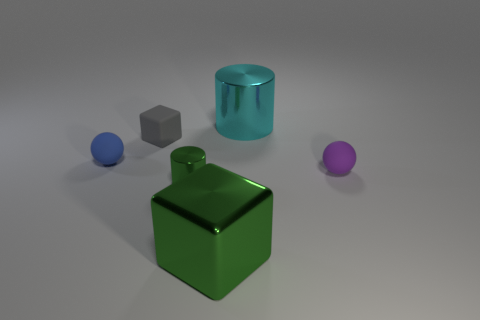Is the number of large metallic cylinders greater than the number of cylinders?
Ensure brevity in your answer.  No. Do the matte ball that is left of the small green metallic object and the big shiny cylinder have the same color?
Your answer should be compact. No. The tiny matte block has what color?
Your answer should be compact. Gray. Are there any small things to the left of the block that is on the right side of the small metal object?
Your answer should be compact. Yes. What is the shape of the object in front of the metal cylinder in front of the purple rubber sphere?
Provide a short and direct response. Cube. Are there fewer tiny yellow matte spheres than green things?
Make the answer very short. Yes. Do the big cylinder and the tiny purple ball have the same material?
Make the answer very short. No. What is the color of the thing that is both right of the small metal cylinder and on the left side of the big cylinder?
Offer a terse response. Green. Is there a brown metal cylinder of the same size as the cyan cylinder?
Make the answer very short. No. What size is the green shiny thing that is on the left side of the big object in front of the tiny gray thing?
Keep it short and to the point. Small. 